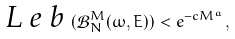<formula> <loc_0><loc_0><loc_500><loc_500>\emph { L e b } ( \mathcal { B } _ { N } ^ { M } ( \omega , E ) ) < e ^ { - c M ^ { a } } ,</formula> 